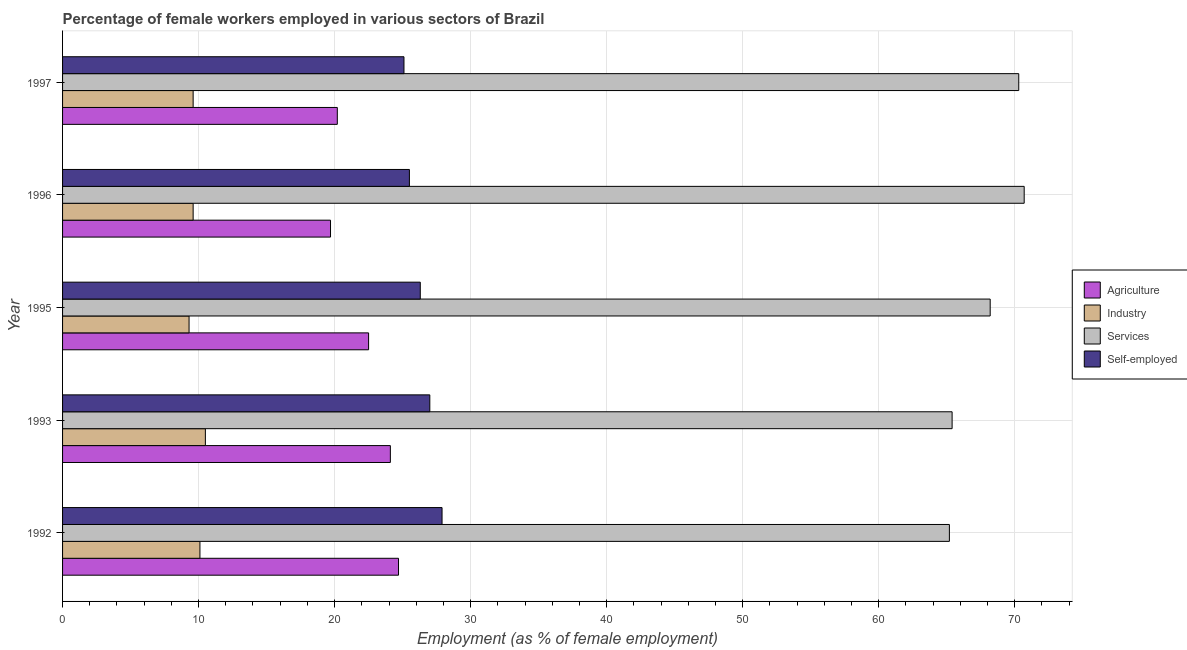How many bars are there on the 1st tick from the top?
Your answer should be very brief. 4. How many bars are there on the 2nd tick from the bottom?
Offer a terse response. 4. What is the percentage of female workers in agriculture in 1992?
Your response must be concise. 24.7. Across all years, what is the maximum percentage of self employed female workers?
Provide a succinct answer. 27.9. Across all years, what is the minimum percentage of self employed female workers?
Give a very brief answer. 25.1. In which year was the percentage of female workers in services minimum?
Your answer should be very brief. 1992. What is the total percentage of female workers in services in the graph?
Make the answer very short. 339.8. What is the difference between the percentage of female workers in agriculture in 1997 and the percentage of female workers in services in 1996?
Make the answer very short. -50.5. What is the average percentage of female workers in industry per year?
Your answer should be very brief. 9.82. In the year 1995, what is the difference between the percentage of female workers in services and percentage of female workers in agriculture?
Offer a terse response. 45.7. In how many years, is the percentage of self employed female workers greater than 6 %?
Offer a terse response. 5. Is the difference between the percentage of female workers in agriculture in 1992 and 1995 greater than the difference between the percentage of female workers in services in 1992 and 1995?
Your answer should be very brief. Yes. What is the difference between the highest and the second highest percentage of self employed female workers?
Ensure brevity in your answer.  0.9. What is the difference between the highest and the lowest percentage of female workers in services?
Make the answer very short. 5.5. In how many years, is the percentage of female workers in agriculture greater than the average percentage of female workers in agriculture taken over all years?
Make the answer very short. 3. Is the sum of the percentage of female workers in industry in 1992 and 1995 greater than the maximum percentage of female workers in agriculture across all years?
Your answer should be very brief. No. What does the 4th bar from the top in 1995 represents?
Keep it short and to the point. Agriculture. What does the 4th bar from the bottom in 1996 represents?
Give a very brief answer. Self-employed. Is it the case that in every year, the sum of the percentage of female workers in agriculture and percentage of female workers in industry is greater than the percentage of female workers in services?
Offer a very short reply. No. How many bars are there?
Your answer should be very brief. 20. What is the difference between two consecutive major ticks on the X-axis?
Offer a terse response. 10. Are the values on the major ticks of X-axis written in scientific E-notation?
Ensure brevity in your answer.  No. How many legend labels are there?
Offer a terse response. 4. What is the title of the graph?
Ensure brevity in your answer.  Percentage of female workers employed in various sectors of Brazil. What is the label or title of the X-axis?
Make the answer very short. Employment (as % of female employment). What is the label or title of the Y-axis?
Make the answer very short. Year. What is the Employment (as % of female employment) of Agriculture in 1992?
Your response must be concise. 24.7. What is the Employment (as % of female employment) of Industry in 1992?
Offer a very short reply. 10.1. What is the Employment (as % of female employment) of Services in 1992?
Keep it short and to the point. 65.2. What is the Employment (as % of female employment) in Self-employed in 1992?
Ensure brevity in your answer.  27.9. What is the Employment (as % of female employment) in Agriculture in 1993?
Offer a terse response. 24.1. What is the Employment (as % of female employment) in Services in 1993?
Give a very brief answer. 65.4. What is the Employment (as % of female employment) in Self-employed in 1993?
Give a very brief answer. 27. What is the Employment (as % of female employment) of Agriculture in 1995?
Keep it short and to the point. 22.5. What is the Employment (as % of female employment) of Industry in 1995?
Give a very brief answer. 9.3. What is the Employment (as % of female employment) of Services in 1995?
Provide a short and direct response. 68.2. What is the Employment (as % of female employment) in Self-employed in 1995?
Ensure brevity in your answer.  26.3. What is the Employment (as % of female employment) of Agriculture in 1996?
Provide a short and direct response. 19.7. What is the Employment (as % of female employment) of Industry in 1996?
Provide a short and direct response. 9.6. What is the Employment (as % of female employment) of Services in 1996?
Give a very brief answer. 70.7. What is the Employment (as % of female employment) of Agriculture in 1997?
Ensure brevity in your answer.  20.2. What is the Employment (as % of female employment) of Industry in 1997?
Offer a terse response. 9.6. What is the Employment (as % of female employment) in Services in 1997?
Give a very brief answer. 70.3. What is the Employment (as % of female employment) in Self-employed in 1997?
Ensure brevity in your answer.  25.1. Across all years, what is the maximum Employment (as % of female employment) in Agriculture?
Your answer should be very brief. 24.7. Across all years, what is the maximum Employment (as % of female employment) in Services?
Your answer should be compact. 70.7. Across all years, what is the maximum Employment (as % of female employment) of Self-employed?
Keep it short and to the point. 27.9. Across all years, what is the minimum Employment (as % of female employment) of Agriculture?
Keep it short and to the point. 19.7. Across all years, what is the minimum Employment (as % of female employment) in Industry?
Keep it short and to the point. 9.3. Across all years, what is the minimum Employment (as % of female employment) of Services?
Your response must be concise. 65.2. Across all years, what is the minimum Employment (as % of female employment) of Self-employed?
Offer a very short reply. 25.1. What is the total Employment (as % of female employment) in Agriculture in the graph?
Your answer should be very brief. 111.2. What is the total Employment (as % of female employment) in Industry in the graph?
Offer a terse response. 49.1. What is the total Employment (as % of female employment) in Services in the graph?
Make the answer very short. 339.8. What is the total Employment (as % of female employment) in Self-employed in the graph?
Ensure brevity in your answer.  131.8. What is the difference between the Employment (as % of female employment) in Industry in 1992 and that in 1993?
Give a very brief answer. -0.4. What is the difference between the Employment (as % of female employment) of Industry in 1992 and that in 1995?
Your response must be concise. 0.8. What is the difference between the Employment (as % of female employment) of Services in 1992 and that in 1995?
Make the answer very short. -3. What is the difference between the Employment (as % of female employment) of Self-employed in 1992 and that in 1995?
Provide a short and direct response. 1.6. What is the difference between the Employment (as % of female employment) in Agriculture in 1992 and that in 1996?
Provide a succinct answer. 5. What is the difference between the Employment (as % of female employment) of Services in 1992 and that in 1996?
Give a very brief answer. -5.5. What is the difference between the Employment (as % of female employment) in Agriculture in 1993 and that in 1995?
Your answer should be very brief. 1.6. What is the difference between the Employment (as % of female employment) in Services in 1993 and that in 1995?
Make the answer very short. -2.8. What is the difference between the Employment (as % of female employment) of Self-employed in 1993 and that in 1995?
Your answer should be very brief. 0.7. What is the difference between the Employment (as % of female employment) of Services in 1993 and that in 1996?
Keep it short and to the point. -5.3. What is the difference between the Employment (as % of female employment) in Self-employed in 1993 and that in 1996?
Offer a very short reply. 1.5. What is the difference between the Employment (as % of female employment) of Agriculture in 1993 and that in 1997?
Ensure brevity in your answer.  3.9. What is the difference between the Employment (as % of female employment) in Services in 1993 and that in 1997?
Offer a very short reply. -4.9. What is the difference between the Employment (as % of female employment) of Agriculture in 1995 and that in 1996?
Keep it short and to the point. 2.8. What is the difference between the Employment (as % of female employment) of Industry in 1995 and that in 1996?
Offer a terse response. -0.3. What is the difference between the Employment (as % of female employment) of Services in 1995 and that in 1996?
Offer a terse response. -2.5. What is the difference between the Employment (as % of female employment) in Agriculture in 1995 and that in 1997?
Keep it short and to the point. 2.3. What is the difference between the Employment (as % of female employment) in Services in 1995 and that in 1997?
Ensure brevity in your answer.  -2.1. What is the difference between the Employment (as % of female employment) of Self-employed in 1995 and that in 1997?
Give a very brief answer. 1.2. What is the difference between the Employment (as % of female employment) of Industry in 1996 and that in 1997?
Your answer should be very brief. 0. What is the difference between the Employment (as % of female employment) in Services in 1996 and that in 1997?
Your response must be concise. 0.4. What is the difference between the Employment (as % of female employment) in Self-employed in 1996 and that in 1997?
Your answer should be very brief. 0.4. What is the difference between the Employment (as % of female employment) in Agriculture in 1992 and the Employment (as % of female employment) in Services in 1993?
Provide a succinct answer. -40.7. What is the difference between the Employment (as % of female employment) of Industry in 1992 and the Employment (as % of female employment) of Services in 1993?
Ensure brevity in your answer.  -55.3. What is the difference between the Employment (as % of female employment) in Industry in 1992 and the Employment (as % of female employment) in Self-employed in 1993?
Provide a short and direct response. -16.9. What is the difference between the Employment (as % of female employment) in Services in 1992 and the Employment (as % of female employment) in Self-employed in 1993?
Provide a succinct answer. 38.2. What is the difference between the Employment (as % of female employment) in Agriculture in 1992 and the Employment (as % of female employment) in Industry in 1995?
Offer a terse response. 15.4. What is the difference between the Employment (as % of female employment) in Agriculture in 1992 and the Employment (as % of female employment) in Services in 1995?
Provide a short and direct response. -43.5. What is the difference between the Employment (as % of female employment) in Agriculture in 1992 and the Employment (as % of female employment) in Self-employed in 1995?
Your answer should be compact. -1.6. What is the difference between the Employment (as % of female employment) in Industry in 1992 and the Employment (as % of female employment) in Services in 1995?
Make the answer very short. -58.1. What is the difference between the Employment (as % of female employment) of Industry in 1992 and the Employment (as % of female employment) of Self-employed in 1995?
Your answer should be very brief. -16.2. What is the difference between the Employment (as % of female employment) in Services in 1992 and the Employment (as % of female employment) in Self-employed in 1995?
Offer a terse response. 38.9. What is the difference between the Employment (as % of female employment) in Agriculture in 1992 and the Employment (as % of female employment) in Services in 1996?
Offer a terse response. -46. What is the difference between the Employment (as % of female employment) of Industry in 1992 and the Employment (as % of female employment) of Services in 1996?
Your response must be concise. -60.6. What is the difference between the Employment (as % of female employment) of Industry in 1992 and the Employment (as % of female employment) of Self-employed in 1996?
Keep it short and to the point. -15.4. What is the difference between the Employment (as % of female employment) of Services in 1992 and the Employment (as % of female employment) of Self-employed in 1996?
Offer a very short reply. 39.7. What is the difference between the Employment (as % of female employment) of Agriculture in 1992 and the Employment (as % of female employment) of Services in 1997?
Your response must be concise. -45.6. What is the difference between the Employment (as % of female employment) of Agriculture in 1992 and the Employment (as % of female employment) of Self-employed in 1997?
Keep it short and to the point. -0.4. What is the difference between the Employment (as % of female employment) in Industry in 1992 and the Employment (as % of female employment) in Services in 1997?
Give a very brief answer. -60.2. What is the difference between the Employment (as % of female employment) of Services in 1992 and the Employment (as % of female employment) of Self-employed in 1997?
Make the answer very short. 40.1. What is the difference between the Employment (as % of female employment) of Agriculture in 1993 and the Employment (as % of female employment) of Services in 1995?
Make the answer very short. -44.1. What is the difference between the Employment (as % of female employment) of Industry in 1993 and the Employment (as % of female employment) of Services in 1995?
Provide a succinct answer. -57.7. What is the difference between the Employment (as % of female employment) in Industry in 1993 and the Employment (as % of female employment) in Self-employed in 1995?
Keep it short and to the point. -15.8. What is the difference between the Employment (as % of female employment) in Services in 1993 and the Employment (as % of female employment) in Self-employed in 1995?
Give a very brief answer. 39.1. What is the difference between the Employment (as % of female employment) in Agriculture in 1993 and the Employment (as % of female employment) in Services in 1996?
Ensure brevity in your answer.  -46.6. What is the difference between the Employment (as % of female employment) in Agriculture in 1993 and the Employment (as % of female employment) in Self-employed in 1996?
Provide a succinct answer. -1.4. What is the difference between the Employment (as % of female employment) in Industry in 1993 and the Employment (as % of female employment) in Services in 1996?
Provide a short and direct response. -60.2. What is the difference between the Employment (as % of female employment) in Industry in 1993 and the Employment (as % of female employment) in Self-employed in 1996?
Your answer should be compact. -15. What is the difference between the Employment (as % of female employment) in Services in 1993 and the Employment (as % of female employment) in Self-employed in 1996?
Offer a very short reply. 39.9. What is the difference between the Employment (as % of female employment) in Agriculture in 1993 and the Employment (as % of female employment) in Industry in 1997?
Your answer should be very brief. 14.5. What is the difference between the Employment (as % of female employment) in Agriculture in 1993 and the Employment (as % of female employment) in Services in 1997?
Ensure brevity in your answer.  -46.2. What is the difference between the Employment (as % of female employment) in Industry in 1993 and the Employment (as % of female employment) in Services in 1997?
Ensure brevity in your answer.  -59.8. What is the difference between the Employment (as % of female employment) of Industry in 1993 and the Employment (as % of female employment) of Self-employed in 1997?
Provide a short and direct response. -14.6. What is the difference between the Employment (as % of female employment) in Services in 1993 and the Employment (as % of female employment) in Self-employed in 1997?
Ensure brevity in your answer.  40.3. What is the difference between the Employment (as % of female employment) in Agriculture in 1995 and the Employment (as % of female employment) in Services in 1996?
Make the answer very short. -48.2. What is the difference between the Employment (as % of female employment) of Industry in 1995 and the Employment (as % of female employment) of Services in 1996?
Provide a succinct answer. -61.4. What is the difference between the Employment (as % of female employment) in Industry in 1995 and the Employment (as % of female employment) in Self-employed in 1996?
Make the answer very short. -16.2. What is the difference between the Employment (as % of female employment) of Services in 1995 and the Employment (as % of female employment) of Self-employed in 1996?
Your answer should be compact. 42.7. What is the difference between the Employment (as % of female employment) in Agriculture in 1995 and the Employment (as % of female employment) in Services in 1997?
Your answer should be compact. -47.8. What is the difference between the Employment (as % of female employment) in Industry in 1995 and the Employment (as % of female employment) in Services in 1997?
Your answer should be very brief. -61. What is the difference between the Employment (as % of female employment) of Industry in 1995 and the Employment (as % of female employment) of Self-employed in 1997?
Your answer should be compact. -15.8. What is the difference between the Employment (as % of female employment) in Services in 1995 and the Employment (as % of female employment) in Self-employed in 1997?
Your answer should be very brief. 43.1. What is the difference between the Employment (as % of female employment) in Agriculture in 1996 and the Employment (as % of female employment) in Services in 1997?
Provide a succinct answer. -50.6. What is the difference between the Employment (as % of female employment) of Agriculture in 1996 and the Employment (as % of female employment) of Self-employed in 1997?
Your answer should be compact. -5.4. What is the difference between the Employment (as % of female employment) in Industry in 1996 and the Employment (as % of female employment) in Services in 1997?
Ensure brevity in your answer.  -60.7. What is the difference between the Employment (as % of female employment) of Industry in 1996 and the Employment (as % of female employment) of Self-employed in 1997?
Offer a very short reply. -15.5. What is the difference between the Employment (as % of female employment) of Services in 1996 and the Employment (as % of female employment) of Self-employed in 1997?
Your answer should be very brief. 45.6. What is the average Employment (as % of female employment) in Agriculture per year?
Keep it short and to the point. 22.24. What is the average Employment (as % of female employment) of Industry per year?
Ensure brevity in your answer.  9.82. What is the average Employment (as % of female employment) in Services per year?
Offer a terse response. 67.96. What is the average Employment (as % of female employment) of Self-employed per year?
Offer a terse response. 26.36. In the year 1992, what is the difference between the Employment (as % of female employment) of Agriculture and Employment (as % of female employment) of Industry?
Offer a very short reply. 14.6. In the year 1992, what is the difference between the Employment (as % of female employment) in Agriculture and Employment (as % of female employment) in Services?
Your answer should be compact. -40.5. In the year 1992, what is the difference between the Employment (as % of female employment) of Agriculture and Employment (as % of female employment) of Self-employed?
Make the answer very short. -3.2. In the year 1992, what is the difference between the Employment (as % of female employment) in Industry and Employment (as % of female employment) in Services?
Offer a very short reply. -55.1. In the year 1992, what is the difference between the Employment (as % of female employment) of Industry and Employment (as % of female employment) of Self-employed?
Your response must be concise. -17.8. In the year 1992, what is the difference between the Employment (as % of female employment) in Services and Employment (as % of female employment) in Self-employed?
Offer a very short reply. 37.3. In the year 1993, what is the difference between the Employment (as % of female employment) in Agriculture and Employment (as % of female employment) in Industry?
Make the answer very short. 13.6. In the year 1993, what is the difference between the Employment (as % of female employment) of Agriculture and Employment (as % of female employment) of Services?
Provide a succinct answer. -41.3. In the year 1993, what is the difference between the Employment (as % of female employment) in Industry and Employment (as % of female employment) in Services?
Keep it short and to the point. -54.9. In the year 1993, what is the difference between the Employment (as % of female employment) of Industry and Employment (as % of female employment) of Self-employed?
Provide a succinct answer. -16.5. In the year 1993, what is the difference between the Employment (as % of female employment) in Services and Employment (as % of female employment) in Self-employed?
Provide a succinct answer. 38.4. In the year 1995, what is the difference between the Employment (as % of female employment) of Agriculture and Employment (as % of female employment) of Industry?
Your answer should be compact. 13.2. In the year 1995, what is the difference between the Employment (as % of female employment) of Agriculture and Employment (as % of female employment) of Services?
Offer a very short reply. -45.7. In the year 1995, what is the difference between the Employment (as % of female employment) of Agriculture and Employment (as % of female employment) of Self-employed?
Give a very brief answer. -3.8. In the year 1995, what is the difference between the Employment (as % of female employment) in Industry and Employment (as % of female employment) in Services?
Keep it short and to the point. -58.9. In the year 1995, what is the difference between the Employment (as % of female employment) in Industry and Employment (as % of female employment) in Self-employed?
Offer a terse response. -17. In the year 1995, what is the difference between the Employment (as % of female employment) in Services and Employment (as % of female employment) in Self-employed?
Ensure brevity in your answer.  41.9. In the year 1996, what is the difference between the Employment (as % of female employment) in Agriculture and Employment (as % of female employment) in Services?
Your answer should be compact. -51. In the year 1996, what is the difference between the Employment (as % of female employment) in Industry and Employment (as % of female employment) in Services?
Your response must be concise. -61.1. In the year 1996, what is the difference between the Employment (as % of female employment) of Industry and Employment (as % of female employment) of Self-employed?
Keep it short and to the point. -15.9. In the year 1996, what is the difference between the Employment (as % of female employment) of Services and Employment (as % of female employment) of Self-employed?
Provide a succinct answer. 45.2. In the year 1997, what is the difference between the Employment (as % of female employment) in Agriculture and Employment (as % of female employment) in Services?
Offer a very short reply. -50.1. In the year 1997, what is the difference between the Employment (as % of female employment) of Agriculture and Employment (as % of female employment) of Self-employed?
Make the answer very short. -4.9. In the year 1997, what is the difference between the Employment (as % of female employment) of Industry and Employment (as % of female employment) of Services?
Offer a terse response. -60.7. In the year 1997, what is the difference between the Employment (as % of female employment) in Industry and Employment (as % of female employment) in Self-employed?
Offer a very short reply. -15.5. In the year 1997, what is the difference between the Employment (as % of female employment) of Services and Employment (as % of female employment) of Self-employed?
Your answer should be very brief. 45.2. What is the ratio of the Employment (as % of female employment) of Agriculture in 1992 to that in 1993?
Provide a short and direct response. 1.02. What is the ratio of the Employment (as % of female employment) in Industry in 1992 to that in 1993?
Your response must be concise. 0.96. What is the ratio of the Employment (as % of female employment) of Services in 1992 to that in 1993?
Offer a terse response. 1. What is the ratio of the Employment (as % of female employment) of Agriculture in 1992 to that in 1995?
Your answer should be compact. 1.1. What is the ratio of the Employment (as % of female employment) of Industry in 1992 to that in 1995?
Offer a terse response. 1.09. What is the ratio of the Employment (as % of female employment) of Services in 1992 to that in 1995?
Provide a short and direct response. 0.96. What is the ratio of the Employment (as % of female employment) in Self-employed in 1992 to that in 1995?
Your response must be concise. 1.06. What is the ratio of the Employment (as % of female employment) in Agriculture in 1992 to that in 1996?
Make the answer very short. 1.25. What is the ratio of the Employment (as % of female employment) in Industry in 1992 to that in 1996?
Your answer should be very brief. 1.05. What is the ratio of the Employment (as % of female employment) in Services in 1992 to that in 1996?
Offer a very short reply. 0.92. What is the ratio of the Employment (as % of female employment) in Self-employed in 1992 to that in 1996?
Make the answer very short. 1.09. What is the ratio of the Employment (as % of female employment) of Agriculture in 1992 to that in 1997?
Give a very brief answer. 1.22. What is the ratio of the Employment (as % of female employment) of Industry in 1992 to that in 1997?
Make the answer very short. 1.05. What is the ratio of the Employment (as % of female employment) in Services in 1992 to that in 1997?
Offer a very short reply. 0.93. What is the ratio of the Employment (as % of female employment) of Self-employed in 1992 to that in 1997?
Provide a succinct answer. 1.11. What is the ratio of the Employment (as % of female employment) of Agriculture in 1993 to that in 1995?
Provide a succinct answer. 1.07. What is the ratio of the Employment (as % of female employment) in Industry in 1993 to that in 1995?
Keep it short and to the point. 1.13. What is the ratio of the Employment (as % of female employment) of Services in 1993 to that in 1995?
Provide a short and direct response. 0.96. What is the ratio of the Employment (as % of female employment) of Self-employed in 1993 to that in 1995?
Make the answer very short. 1.03. What is the ratio of the Employment (as % of female employment) of Agriculture in 1993 to that in 1996?
Provide a succinct answer. 1.22. What is the ratio of the Employment (as % of female employment) of Industry in 1993 to that in 1996?
Provide a succinct answer. 1.09. What is the ratio of the Employment (as % of female employment) of Services in 1993 to that in 1996?
Make the answer very short. 0.93. What is the ratio of the Employment (as % of female employment) of Self-employed in 1993 to that in 1996?
Your response must be concise. 1.06. What is the ratio of the Employment (as % of female employment) in Agriculture in 1993 to that in 1997?
Keep it short and to the point. 1.19. What is the ratio of the Employment (as % of female employment) of Industry in 1993 to that in 1997?
Your response must be concise. 1.09. What is the ratio of the Employment (as % of female employment) in Services in 1993 to that in 1997?
Keep it short and to the point. 0.93. What is the ratio of the Employment (as % of female employment) of Self-employed in 1993 to that in 1997?
Your answer should be compact. 1.08. What is the ratio of the Employment (as % of female employment) of Agriculture in 1995 to that in 1996?
Provide a succinct answer. 1.14. What is the ratio of the Employment (as % of female employment) of Industry in 1995 to that in 1996?
Give a very brief answer. 0.97. What is the ratio of the Employment (as % of female employment) in Services in 1995 to that in 1996?
Ensure brevity in your answer.  0.96. What is the ratio of the Employment (as % of female employment) of Self-employed in 1995 to that in 1996?
Keep it short and to the point. 1.03. What is the ratio of the Employment (as % of female employment) in Agriculture in 1995 to that in 1997?
Offer a very short reply. 1.11. What is the ratio of the Employment (as % of female employment) of Industry in 1995 to that in 1997?
Ensure brevity in your answer.  0.97. What is the ratio of the Employment (as % of female employment) in Services in 1995 to that in 1997?
Your answer should be very brief. 0.97. What is the ratio of the Employment (as % of female employment) of Self-employed in 1995 to that in 1997?
Provide a short and direct response. 1.05. What is the ratio of the Employment (as % of female employment) in Agriculture in 1996 to that in 1997?
Keep it short and to the point. 0.98. What is the ratio of the Employment (as % of female employment) of Industry in 1996 to that in 1997?
Make the answer very short. 1. What is the ratio of the Employment (as % of female employment) of Services in 1996 to that in 1997?
Provide a succinct answer. 1.01. What is the ratio of the Employment (as % of female employment) in Self-employed in 1996 to that in 1997?
Offer a terse response. 1.02. What is the difference between the highest and the second highest Employment (as % of female employment) of Agriculture?
Your answer should be compact. 0.6. What is the difference between the highest and the second highest Employment (as % of female employment) of Industry?
Ensure brevity in your answer.  0.4. What is the difference between the highest and the second highest Employment (as % of female employment) of Services?
Offer a terse response. 0.4. What is the difference between the highest and the second highest Employment (as % of female employment) of Self-employed?
Ensure brevity in your answer.  0.9. What is the difference between the highest and the lowest Employment (as % of female employment) of Services?
Your answer should be very brief. 5.5. What is the difference between the highest and the lowest Employment (as % of female employment) in Self-employed?
Your answer should be very brief. 2.8. 